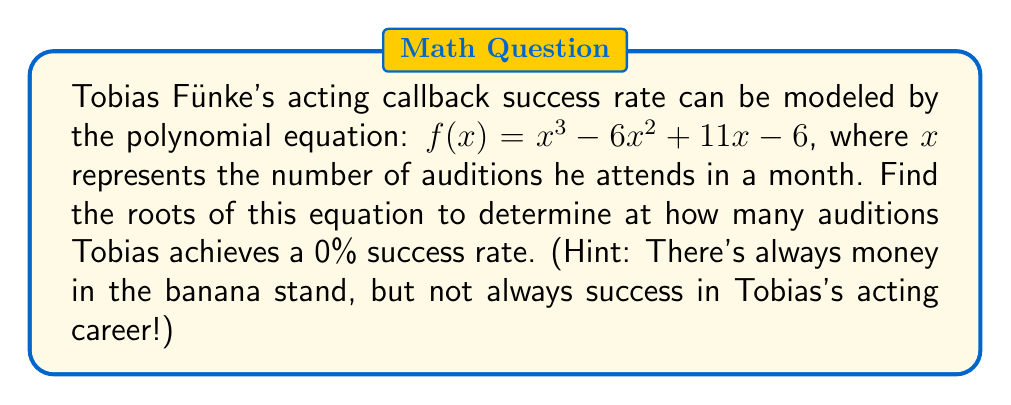Solve this math problem. To find the roots of the polynomial equation, we need to factor $f(x) = x^3 - 6x^2 + 11x - 6$.

Step 1: Check for rational roots using the rational root theorem.
Possible rational roots: $\pm 1, \pm 2, \pm 3, \pm 6$

Step 2: Test these values in the equation. We find that $x = 1$ is a root.

Step 3: Use polynomial long division to divide $f(x)$ by $(x - 1)$:

$x^3 - 6x^2 + 11x - 6 = (x - 1)(x^2 - 5x + 6)$

Step 4: Factor the quadratic term:
$x^2 - 5x + 6 = (x - 2)(x - 3)$

Step 5: Write the fully factored polynomial:
$f(x) = (x - 1)(x - 2)(x - 3)$

Therefore, the roots of the equation are $x = 1, 2,$ and $3$.

"I'm afraid I just blue myself" - Tobias Fünke, probably realizing his acting career isn't taking off as planned.
Answer: $x = 1, 2, 3$ 